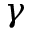Convert formula to latex. <formula><loc_0><loc_0><loc_500><loc_500>\gamma</formula> 